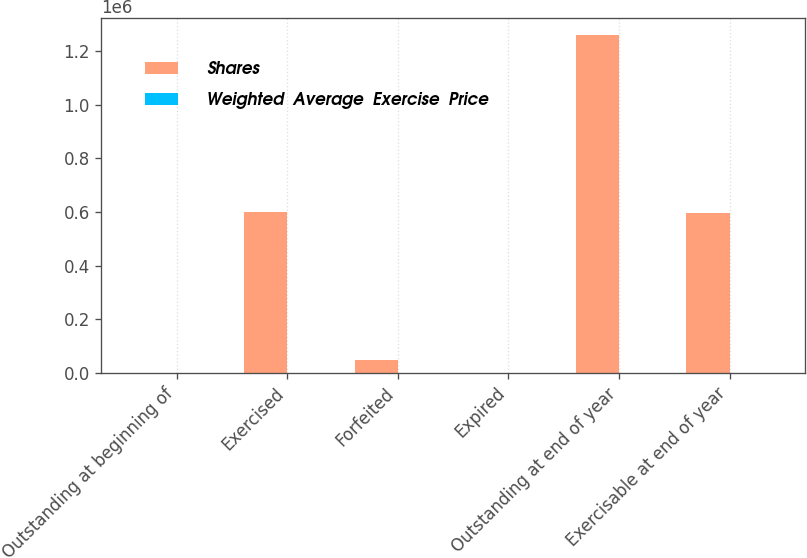Convert chart to OTSL. <chart><loc_0><loc_0><loc_500><loc_500><stacked_bar_chart><ecel><fcel>Outstanding at beginning of<fcel>Exercised<fcel>Forfeited<fcel>Expired<fcel>Outstanding at end of year<fcel>Exercisable at end of year<nl><fcel>Shares<fcel>108.2<fcel>598249<fcel>46161<fcel>438<fcel>1.26118e+06<fcel>595086<nl><fcel>Weighted  Average  Exercise  Price<fcel>65.73<fcel>55.93<fcel>80.41<fcel>108.2<fcel>75.71<fcel>60.85<nl></chart> 